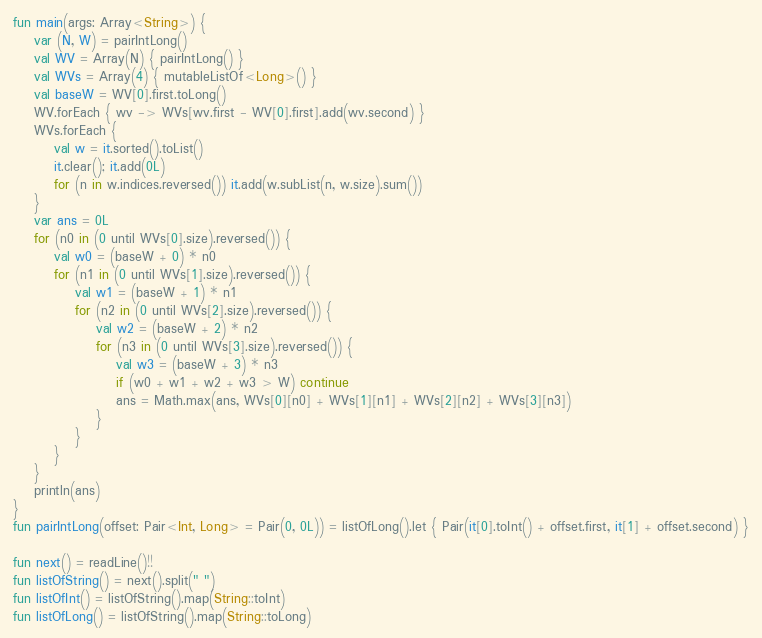Convert code to text. <code><loc_0><loc_0><loc_500><loc_500><_Kotlin_>fun main(args: Array<String>) {
    var (N, W) = pairIntLong()
    val WV = Array(N) { pairIntLong() }
    val WVs = Array(4) { mutableListOf<Long>() }
    val baseW = WV[0].first.toLong()
    WV.forEach { wv -> WVs[wv.first - WV[0].first].add(wv.second) }
    WVs.forEach {
        val w = it.sorted().toList()
        it.clear(); it.add(0L)
        for (n in w.indices.reversed()) it.add(w.subList(n, w.size).sum())
    }
    var ans = 0L
    for (n0 in (0 until WVs[0].size).reversed()) {
        val w0 = (baseW + 0) * n0
        for (n1 in (0 until WVs[1].size).reversed()) {
            val w1 = (baseW + 1) * n1
            for (n2 in (0 until WVs[2].size).reversed()) {
                val w2 = (baseW + 2) * n2
                for (n3 in (0 until WVs[3].size).reversed()) {
                    val w3 = (baseW + 3) * n3
                    if (w0 + w1 + w2 + w3 > W) continue
                    ans = Math.max(ans, WVs[0][n0] + WVs[1][n1] + WVs[2][n2] + WVs[3][n3])
                }
            }
        }
    }
    println(ans)
}
fun pairIntLong(offset: Pair<Int, Long> = Pair(0, 0L)) = listOfLong().let { Pair(it[0].toInt() + offset.first, it[1] + offset.second) }

fun next() = readLine()!!
fun listOfString() = next().split(" ")
fun listOfInt() = listOfString().map(String::toInt)
fun listOfLong() = listOfString().map(String::toLong)
</code> 